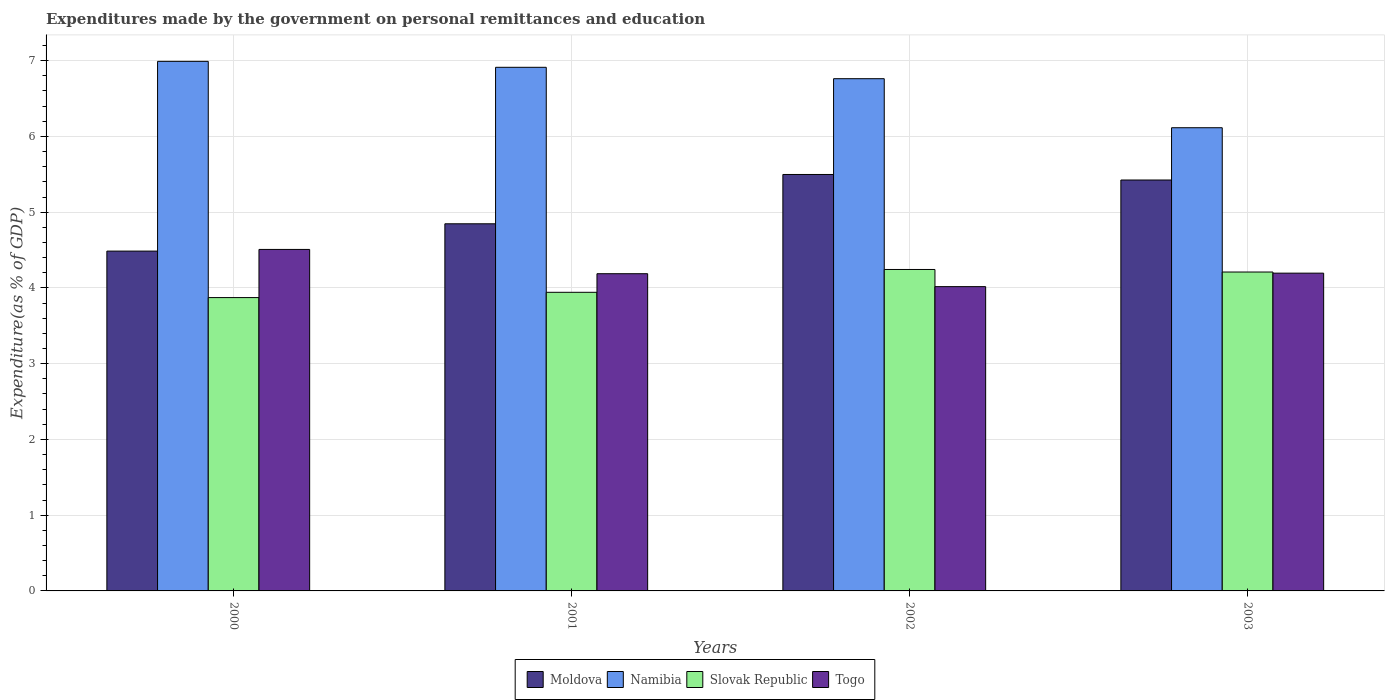How many different coloured bars are there?
Make the answer very short. 4. How many bars are there on the 1st tick from the left?
Provide a short and direct response. 4. How many bars are there on the 2nd tick from the right?
Give a very brief answer. 4. In how many cases, is the number of bars for a given year not equal to the number of legend labels?
Provide a short and direct response. 0. What is the expenditures made by the government on personal remittances and education in Namibia in 2002?
Make the answer very short. 6.76. Across all years, what is the maximum expenditures made by the government on personal remittances and education in Namibia?
Your answer should be compact. 6.99. Across all years, what is the minimum expenditures made by the government on personal remittances and education in Slovak Republic?
Give a very brief answer. 3.87. In which year was the expenditures made by the government on personal remittances and education in Slovak Republic maximum?
Your answer should be very brief. 2002. In which year was the expenditures made by the government on personal remittances and education in Moldova minimum?
Make the answer very short. 2000. What is the total expenditures made by the government on personal remittances and education in Togo in the graph?
Offer a very short reply. 16.91. What is the difference between the expenditures made by the government on personal remittances and education in Namibia in 2000 and that in 2001?
Make the answer very short. 0.08. What is the difference between the expenditures made by the government on personal remittances and education in Slovak Republic in 2000 and the expenditures made by the government on personal remittances and education in Togo in 2003?
Provide a succinct answer. -0.32. What is the average expenditures made by the government on personal remittances and education in Moldova per year?
Your response must be concise. 5.06. In the year 2001, what is the difference between the expenditures made by the government on personal remittances and education in Slovak Republic and expenditures made by the government on personal remittances and education in Moldova?
Provide a short and direct response. -0.9. In how many years, is the expenditures made by the government on personal remittances and education in Slovak Republic greater than 2.8 %?
Provide a succinct answer. 4. What is the ratio of the expenditures made by the government on personal remittances and education in Namibia in 2001 to that in 2003?
Provide a succinct answer. 1.13. Is the expenditures made by the government on personal remittances and education in Slovak Republic in 2001 less than that in 2002?
Keep it short and to the point. Yes. Is the difference between the expenditures made by the government on personal remittances and education in Slovak Republic in 2000 and 2003 greater than the difference between the expenditures made by the government on personal remittances and education in Moldova in 2000 and 2003?
Give a very brief answer. Yes. What is the difference between the highest and the second highest expenditures made by the government on personal remittances and education in Moldova?
Your answer should be very brief. 0.07. What is the difference between the highest and the lowest expenditures made by the government on personal remittances and education in Togo?
Your response must be concise. 0.49. Is the sum of the expenditures made by the government on personal remittances and education in Namibia in 2001 and 2003 greater than the maximum expenditures made by the government on personal remittances and education in Slovak Republic across all years?
Provide a short and direct response. Yes. What does the 2nd bar from the left in 2003 represents?
Keep it short and to the point. Namibia. What does the 2nd bar from the right in 2001 represents?
Your answer should be compact. Slovak Republic. How many bars are there?
Offer a very short reply. 16. What is the difference between two consecutive major ticks on the Y-axis?
Your answer should be very brief. 1. Does the graph contain any zero values?
Your answer should be very brief. No. Does the graph contain grids?
Offer a very short reply. Yes. How many legend labels are there?
Offer a terse response. 4. What is the title of the graph?
Ensure brevity in your answer.  Expenditures made by the government on personal remittances and education. Does "New Zealand" appear as one of the legend labels in the graph?
Ensure brevity in your answer.  No. What is the label or title of the X-axis?
Give a very brief answer. Years. What is the label or title of the Y-axis?
Your response must be concise. Expenditure(as % of GDP). What is the Expenditure(as % of GDP) of Moldova in 2000?
Your response must be concise. 4.49. What is the Expenditure(as % of GDP) in Namibia in 2000?
Your answer should be very brief. 6.99. What is the Expenditure(as % of GDP) in Slovak Republic in 2000?
Offer a very short reply. 3.87. What is the Expenditure(as % of GDP) in Togo in 2000?
Your answer should be very brief. 4.51. What is the Expenditure(as % of GDP) in Moldova in 2001?
Ensure brevity in your answer.  4.85. What is the Expenditure(as % of GDP) of Namibia in 2001?
Ensure brevity in your answer.  6.91. What is the Expenditure(as % of GDP) in Slovak Republic in 2001?
Make the answer very short. 3.94. What is the Expenditure(as % of GDP) of Togo in 2001?
Make the answer very short. 4.19. What is the Expenditure(as % of GDP) in Moldova in 2002?
Keep it short and to the point. 5.5. What is the Expenditure(as % of GDP) of Namibia in 2002?
Your response must be concise. 6.76. What is the Expenditure(as % of GDP) in Slovak Republic in 2002?
Give a very brief answer. 4.24. What is the Expenditure(as % of GDP) of Togo in 2002?
Provide a succinct answer. 4.02. What is the Expenditure(as % of GDP) of Moldova in 2003?
Provide a succinct answer. 5.42. What is the Expenditure(as % of GDP) of Namibia in 2003?
Your answer should be compact. 6.12. What is the Expenditure(as % of GDP) in Slovak Republic in 2003?
Your response must be concise. 4.21. What is the Expenditure(as % of GDP) of Togo in 2003?
Ensure brevity in your answer.  4.2. Across all years, what is the maximum Expenditure(as % of GDP) of Moldova?
Offer a terse response. 5.5. Across all years, what is the maximum Expenditure(as % of GDP) of Namibia?
Provide a succinct answer. 6.99. Across all years, what is the maximum Expenditure(as % of GDP) in Slovak Republic?
Ensure brevity in your answer.  4.24. Across all years, what is the maximum Expenditure(as % of GDP) of Togo?
Give a very brief answer. 4.51. Across all years, what is the minimum Expenditure(as % of GDP) of Moldova?
Keep it short and to the point. 4.49. Across all years, what is the minimum Expenditure(as % of GDP) of Namibia?
Keep it short and to the point. 6.12. Across all years, what is the minimum Expenditure(as % of GDP) of Slovak Republic?
Give a very brief answer. 3.87. Across all years, what is the minimum Expenditure(as % of GDP) of Togo?
Your response must be concise. 4.02. What is the total Expenditure(as % of GDP) in Moldova in the graph?
Provide a succinct answer. 20.26. What is the total Expenditure(as % of GDP) in Namibia in the graph?
Give a very brief answer. 26.78. What is the total Expenditure(as % of GDP) of Slovak Republic in the graph?
Offer a very short reply. 16.27. What is the total Expenditure(as % of GDP) of Togo in the graph?
Give a very brief answer. 16.91. What is the difference between the Expenditure(as % of GDP) of Moldova in 2000 and that in 2001?
Give a very brief answer. -0.36. What is the difference between the Expenditure(as % of GDP) of Namibia in 2000 and that in 2001?
Keep it short and to the point. 0.08. What is the difference between the Expenditure(as % of GDP) in Slovak Republic in 2000 and that in 2001?
Your response must be concise. -0.07. What is the difference between the Expenditure(as % of GDP) in Togo in 2000 and that in 2001?
Your answer should be compact. 0.32. What is the difference between the Expenditure(as % of GDP) of Moldova in 2000 and that in 2002?
Keep it short and to the point. -1.01. What is the difference between the Expenditure(as % of GDP) in Namibia in 2000 and that in 2002?
Your response must be concise. 0.23. What is the difference between the Expenditure(as % of GDP) of Slovak Republic in 2000 and that in 2002?
Offer a very short reply. -0.37. What is the difference between the Expenditure(as % of GDP) in Togo in 2000 and that in 2002?
Make the answer very short. 0.49. What is the difference between the Expenditure(as % of GDP) of Moldova in 2000 and that in 2003?
Provide a succinct answer. -0.94. What is the difference between the Expenditure(as % of GDP) in Namibia in 2000 and that in 2003?
Keep it short and to the point. 0.88. What is the difference between the Expenditure(as % of GDP) of Slovak Republic in 2000 and that in 2003?
Keep it short and to the point. -0.34. What is the difference between the Expenditure(as % of GDP) of Togo in 2000 and that in 2003?
Your answer should be very brief. 0.31. What is the difference between the Expenditure(as % of GDP) of Moldova in 2001 and that in 2002?
Make the answer very short. -0.65. What is the difference between the Expenditure(as % of GDP) of Namibia in 2001 and that in 2002?
Give a very brief answer. 0.15. What is the difference between the Expenditure(as % of GDP) in Slovak Republic in 2001 and that in 2002?
Give a very brief answer. -0.3. What is the difference between the Expenditure(as % of GDP) of Togo in 2001 and that in 2002?
Provide a short and direct response. 0.17. What is the difference between the Expenditure(as % of GDP) in Moldova in 2001 and that in 2003?
Your answer should be compact. -0.58. What is the difference between the Expenditure(as % of GDP) in Namibia in 2001 and that in 2003?
Your answer should be very brief. 0.8. What is the difference between the Expenditure(as % of GDP) in Slovak Republic in 2001 and that in 2003?
Offer a very short reply. -0.27. What is the difference between the Expenditure(as % of GDP) in Togo in 2001 and that in 2003?
Keep it short and to the point. -0.01. What is the difference between the Expenditure(as % of GDP) in Moldova in 2002 and that in 2003?
Your answer should be compact. 0.07. What is the difference between the Expenditure(as % of GDP) in Namibia in 2002 and that in 2003?
Provide a short and direct response. 0.65. What is the difference between the Expenditure(as % of GDP) in Slovak Republic in 2002 and that in 2003?
Ensure brevity in your answer.  0.03. What is the difference between the Expenditure(as % of GDP) of Togo in 2002 and that in 2003?
Make the answer very short. -0.18. What is the difference between the Expenditure(as % of GDP) of Moldova in 2000 and the Expenditure(as % of GDP) of Namibia in 2001?
Ensure brevity in your answer.  -2.43. What is the difference between the Expenditure(as % of GDP) in Moldova in 2000 and the Expenditure(as % of GDP) in Slovak Republic in 2001?
Your answer should be very brief. 0.54. What is the difference between the Expenditure(as % of GDP) of Moldova in 2000 and the Expenditure(as % of GDP) of Togo in 2001?
Provide a short and direct response. 0.3. What is the difference between the Expenditure(as % of GDP) in Namibia in 2000 and the Expenditure(as % of GDP) in Slovak Republic in 2001?
Your response must be concise. 3.05. What is the difference between the Expenditure(as % of GDP) of Namibia in 2000 and the Expenditure(as % of GDP) of Togo in 2001?
Your answer should be very brief. 2.8. What is the difference between the Expenditure(as % of GDP) of Slovak Republic in 2000 and the Expenditure(as % of GDP) of Togo in 2001?
Offer a very short reply. -0.32. What is the difference between the Expenditure(as % of GDP) of Moldova in 2000 and the Expenditure(as % of GDP) of Namibia in 2002?
Offer a very short reply. -2.28. What is the difference between the Expenditure(as % of GDP) of Moldova in 2000 and the Expenditure(as % of GDP) of Slovak Republic in 2002?
Offer a very short reply. 0.24. What is the difference between the Expenditure(as % of GDP) of Moldova in 2000 and the Expenditure(as % of GDP) of Togo in 2002?
Give a very brief answer. 0.47. What is the difference between the Expenditure(as % of GDP) of Namibia in 2000 and the Expenditure(as % of GDP) of Slovak Republic in 2002?
Your answer should be compact. 2.75. What is the difference between the Expenditure(as % of GDP) in Namibia in 2000 and the Expenditure(as % of GDP) in Togo in 2002?
Keep it short and to the point. 2.97. What is the difference between the Expenditure(as % of GDP) of Slovak Republic in 2000 and the Expenditure(as % of GDP) of Togo in 2002?
Give a very brief answer. -0.14. What is the difference between the Expenditure(as % of GDP) in Moldova in 2000 and the Expenditure(as % of GDP) in Namibia in 2003?
Make the answer very short. -1.63. What is the difference between the Expenditure(as % of GDP) of Moldova in 2000 and the Expenditure(as % of GDP) of Slovak Republic in 2003?
Your response must be concise. 0.28. What is the difference between the Expenditure(as % of GDP) of Moldova in 2000 and the Expenditure(as % of GDP) of Togo in 2003?
Your response must be concise. 0.29. What is the difference between the Expenditure(as % of GDP) of Namibia in 2000 and the Expenditure(as % of GDP) of Slovak Republic in 2003?
Provide a short and direct response. 2.78. What is the difference between the Expenditure(as % of GDP) of Namibia in 2000 and the Expenditure(as % of GDP) of Togo in 2003?
Your answer should be compact. 2.8. What is the difference between the Expenditure(as % of GDP) of Slovak Republic in 2000 and the Expenditure(as % of GDP) of Togo in 2003?
Offer a terse response. -0.32. What is the difference between the Expenditure(as % of GDP) of Moldova in 2001 and the Expenditure(as % of GDP) of Namibia in 2002?
Keep it short and to the point. -1.92. What is the difference between the Expenditure(as % of GDP) in Moldova in 2001 and the Expenditure(as % of GDP) in Slovak Republic in 2002?
Make the answer very short. 0.6. What is the difference between the Expenditure(as % of GDP) of Moldova in 2001 and the Expenditure(as % of GDP) of Togo in 2002?
Give a very brief answer. 0.83. What is the difference between the Expenditure(as % of GDP) in Namibia in 2001 and the Expenditure(as % of GDP) in Slovak Republic in 2002?
Offer a terse response. 2.67. What is the difference between the Expenditure(as % of GDP) in Namibia in 2001 and the Expenditure(as % of GDP) in Togo in 2002?
Provide a short and direct response. 2.9. What is the difference between the Expenditure(as % of GDP) in Slovak Republic in 2001 and the Expenditure(as % of GDP) in Togo in 2002?
Your response must be concise. -0.07. What is the difference between the Expenditure(as % of GDP) of Moldova in 2001 and the Expenditure(as % of GDP) of Namibia in 2003?
Offer a very short reply. -1.27. What is the difference between the Expenditure(as % of GDP) of Moldova in 2001 and the Expenditure(as % of GDP) of Slovak Republic in 2003?
Give a very brief answer. 0.64. What is the difference between the Expenditure(as % of GDP) in Moldova in 2001 and the Expenditure(as % of GDP) in Togo in 2003?
Give a very brief answer. 0.65. What is the difference between the Expenditure(as % of GDP) in Namibia in 2001 and the Expenditure(as % of GDP) in Slovak Republic in 2003?
Your response must be concise. 2.7. What is the difference between the Expenditure(as % of GDP) of Namibia in 2001 and the Expenditure(as % of GDP) of Togo in 2003?
Keep it short and to the point. 2.72. What is the difference between the Expenditure(as % of GDP) in Slovak Republic in 2001 and the Expenditure(as % of GDP) in Togo in 2003?
Ensure brevity in your answer.  -0.25. What is the difference between the Expenditure(as % of GDP) of Moldova in 2002 and the Expenditure(as % of GDP) of Namibia in 2003?
Provide a succinct answer. -0.62. What is the difference between the Expenditure(as % of GDP) in Moldova in 2002 and the Expenditure(as % of GDP) in Slovak Republic in 2003?
Keep it short and to the point. 1.29. What is the difference between the Expenditure(as % of GDP) of Moldova in 2002 and the Expenditure(as % of GDP) of Togo in 2003?
Your response must be concise. 1.3. What is the difference between the Expenditure(as % of GDP) in Namibia in 2002 and the Expenditure(as % of GDP) in Slovak Republic in 2003?
Ensure brevity in your answer.  2.55. What is the difference between the Expenditure(as % of GDP) in Namibia in 2002 and the Expenditure(as % of GDP) in Togo in 2003?
Provide a short and direct response. 2.57. What is the difference between the Expenditure(as % of GDP) of Slovak Republic in 2002 and the Expenditure(as % of GDP) of Togo in 2003?
Offer a terse response. 0.05. What is the average Expenditure(as % of GDP) of Moldova per year?
Offer a very short reply. 5.06. What is the average Expenditure(as % of GDP) of Namibia per year?
Provide a succinct answer. 6.7. What is the average Expenditure(as % of GDP) of Slovak Republic per year?
Give a very brief answer. 4.07. What is the average Expenditure(as % of GDP) of Togo per year?
Ensure brevity in your answer.  4.23. In the year 2000, what is the difference between the Expenditure(as % of GDP) of Moldova and Expenditure(as % of GDP) of Namibia?
Offer a terse response. -2.5. In the year 2000, what is the difference between the Expenditure(as % of GDP) in Moldova and Expenditure(as % of GDP) in Slovak Republic?
Your answer should be very brief. 0.61. In the year 2000, what is the difference between the Expenditure(as % of GDP) in Moldova and Expenditure(as % of GDP) in Togo?
Ensure brevity in your answer.  -0.02. In the year 2000, what is the difference between the Expenditure(as % of GDP) in Namibia and Expenditure(as % of GDP) in Slovak Republic?
Ensure brevity in your answer.  3.12. In the year 2000, what is the difference between the Expenditure(as % of GDP) of Namibia and Expenditure(as % of GDP) of Togo?
Your answer should be very brief. 2.48. In the year 2000, what is the difference between the Expenditure(as % of GDP) in Slovak Republic and Expenditure(as % of GDP) in Togo?
Make the answer very short. -0.64. In the year 2001, what is the difference between the Expenditure(as % of GDP) in Moldova and Expenditure(as % of GDP) in Namibia?
Your response must be concise. -2.07. In the year 2001, what is the difference between the Expenditure(as % of GDP) of Moldova and Expenditure(as % of GDP) of Slovak Republic?
Make the answer very short. 0.9. In the year 2001, what is the difference between the Expenditure(as % of GDP) in Moldova and Expenditure(as % of GDP) in Togo?
Ensure brevity in your answer.  0.66. In the year 2001, what is the difference between the Expenditure(as % of GDP) in Namibia and Expenditure(as % of GDP) in Slovak Republic?
Ensure brevity in your answer.  2.97. In the year 2001, what is the difference between the Expenditure(as % of GDP) in Namibia and Expenditure(as % of GDP) in Togo?
Your answer should be very brief. 2.73. In the year 2001, what is the difference between the Expenditure(as % of GDP) of Slovak Republic and Expenditure(as % of GDP) of Togo?
Give a very brief answer. -0.25. In the year 2002, what is the difference between the Expenditure(as % of GDP) of Moldova and Expenditure(as % of GDP) of Namibia?
Make the answer very short. -1.26. In the year 2002, what is the difference between the Expenditure(as % of GDP) of Moldova and Expenditure(as % of GDP) of Slovak Republic?
Offer a terse response. 1.25. In the year 2002, what is the difference between the Expenditure(as % of GDP) of Moldova and Expenditure(as % of GDP) of Togo?
Offer a terse response. 1.48. In the year 2002, what is the difference between the Expenditure(as % of GDP) in Namibia and Expenditure(as % of GDP) in Slovak Republic?
Ensure brevity in your answer.  2.52. In the year 2002, what is the difference between the Expenditure(as % of GDP) of Namibia and Expenditure(as % of GDP) of Togo?
Offer a terse response. 2.75. In the year 2002, what is the difference between the Expenditure(as % of GDP) of Slovak Republic and Expenditure(as % of GDP) of Togo?
Make the answer very short. 0.23. In the year 2003, what is the difference between the Expenditure(as % of GDP) in Moldova and Expenditure(as % of GDP) in Namibia?
Provide a succinct answer. -0.69. In the year 2003, what is the difference between the Expenditure(as % of GDP) in Moldova and Expenditure(as % of GDP) in Slovak Republic?
Your response must be concise. 1.21. In the year 2003, what is the difference between the Expenditure(as % of GDP) of Moldova and Expenditure(as % of GDP) of Togo?
Offer a very short reply. 1.23. In the year 2003, what is the difference between the Expenditure(as % of GDP) of Namibia and Expenditure(as % of GDP) of Slovak Republic?
Give a very brief answer. 1.91. In the year 2003, what is the difference between the Expenditure(as % of GDP) of Namibia and Expenditure(as % of GDP) of Togo?
Give a very brief answer. 1.92. In the year 2003, what is the difference between the Expenditure(as % of GDP) in Slovak Republic and Expenditure(as % of GDP) in Togo?
Offer a very short reply. 0.01. What is the ratio of the Expenditure(as % of GDP) in Moldova in 2000 to that in 2001?
Provide a short and direct response. 0.93. What is the ratio of the Expenditure(as % of GDP) in Namibia in 2000 to that in 2001?
Your answer should be very brief. 1.01. What is the ratio of the Expenditure(as % of GDP) of Slovak Republic in 2000 to that in 2001?
Make the answer very short. 0.98. What is the ratio of the Expenditure(as % of GDP) in Togo in 2000 to that in 2001?
Offer a very short reply. 1.08. What is the ratio of the Expenditure(as % of GDP) of Moldova in 2000 to that in 2002?
Your answer should be very brief. 0.82. What is the ratio of the Expenditure(as % of GDP) in Namibia in 2000 to that in 2002?
Provide a succinct answer. 1.03. What is the ratio of the Expenditure(as % of GDP) in Slovak Republic in 2000 to that in 2002?
Keep it short and to the point. 0.91. What is the ratio of the Expenditure(as % of GDP) in Togo in 2000 to that in 2002?
Your response must be concise. 1.12. What is the ratio of the Expenditure(as % of GDP) of Moldova in 2000 to that in 2003?
Give a very brief answer. 0.83. What is the ratio of the Expenditure(as % of GDP) of Namibia in 2000 to that in 2003?
Make the answer very short. 1.14. What is the ratio of the Expenditure(as % of GDP) of Slovak Republic in 2000 to that in 2003?
Give a very brief answer. 0.92. What is the ratio of the Expenditure(as % of GDP) of Togo in 2000 to that in 2003?
Your answer should be very brief. 1.07. What is the ratio of the Expenditure(as % of GDP) in Moldova in 2001 to that in 2002?
Your answer should be compact. 0.88. What is the ratio of the Expenditure(as % of GDP) of Namibia in 2001 to that in 2002?
Keep it short and to the point. 1.02. What is the ratio of the Expenditure(as % of GDP) in Slovak Republic in 2001 to that in 2002?
Provide a short and direct response. 0.93. What is the ratio of the Expenditure(as % of GDP) in Togo in 2001 to that in 2002?
Offer a terse response. 1.04. What is the ratio of the Expenditure(as % of GDP) in Moldova in 2001 to that in 2003?
Ensure brevity in your answer.  0.89. What is the ratio of the Expenditure(as % of GDP) of Namibia in 2001 to that in 2003?
Your response must be concise. 1.13. What is the ratio of the Expenditure(as % of GDP) of Slovak Republic in 2001 to that in 2003?
Give a very brief answer. 0.94. What is the ratio of the Expenditure(as % of GDP) in Togo in 2001 to that in 2003?
Your response must be concise. 1. What is the ratio of the Expenditure(as % of GDP) of Moldova in 2002 to that in 2003?
Make the answer very short. 1.01. What is the ratio of the Expenditure(as % of GDP) in Namibia in 2002 to that in 2003?
Ensure brevity in your answer.  1.11. What is the ratio of the Expenditure(as % of GDP) of Slovak Republic in 2002 to that in 2003?
Provide a short and direct response. 1.01. What is the ratio of the Expenditure(as % of GDP) of Togo in 2002 to that in 2003?
Your response must be concise. 0.96. What is the difference between the highest and the second highest Expenditure(as % of GDP) of Moldova?
Provide a succinct answer. 0.07. What is the difference between the highest and the second highest Expenditure(as % of GDP) of Namibia?
Provide a short and direct response. 0.08. What is the difference between the highest and the second highest Expenditure(as % of GDP) of Slovak Republic?
Keep it short and to the point. 0.03. What is the difference between the highest and the second highest Expenditure(as % of GDP) in Togo?
Ensure brevity in your answer.  0.31. What is the difference between the highest and the lowest Expenditure(as % of GDP) of Moldova?
Ensure brevity in your answer.  1.01. What is the difference between the highest and the lowest Expenditure(as % of GDP) in Namibia?
Your answer should be very brief. 0.88. What is the difference between the highest and the lowest Expenditure(as % of GDP) of Slovak Republic?
Your response must be concise. 0.37. What is the difference between the highest and the lowest Expenditure(as % of GDP) of Togo?
Keep it short and to the point. 0.49. 